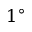Convert formula to latex. <formula><loc_0><loc_0><loc_500><loc_500>1 ^ { \circ }</formula> 